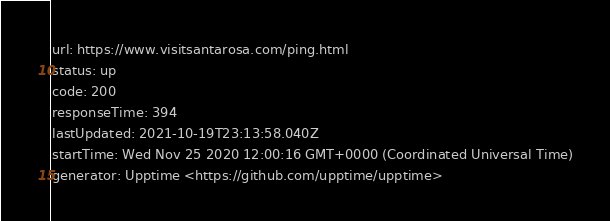<code> <loc_0><loc_0><loc_500><loc_500><_YAML_>url: https://www.visitsantarosa.com/ping.html
status: up
code: 200
responseTime: 394
lastUpdated: 2021-10-19T23:13:58.040Z
startTime: Wed Nov 25 2020 12:00:16 GMT+0000 (Coordinated Universal Time)
generator: Upptime <https://github.com/upptime/upptime>
</code> 